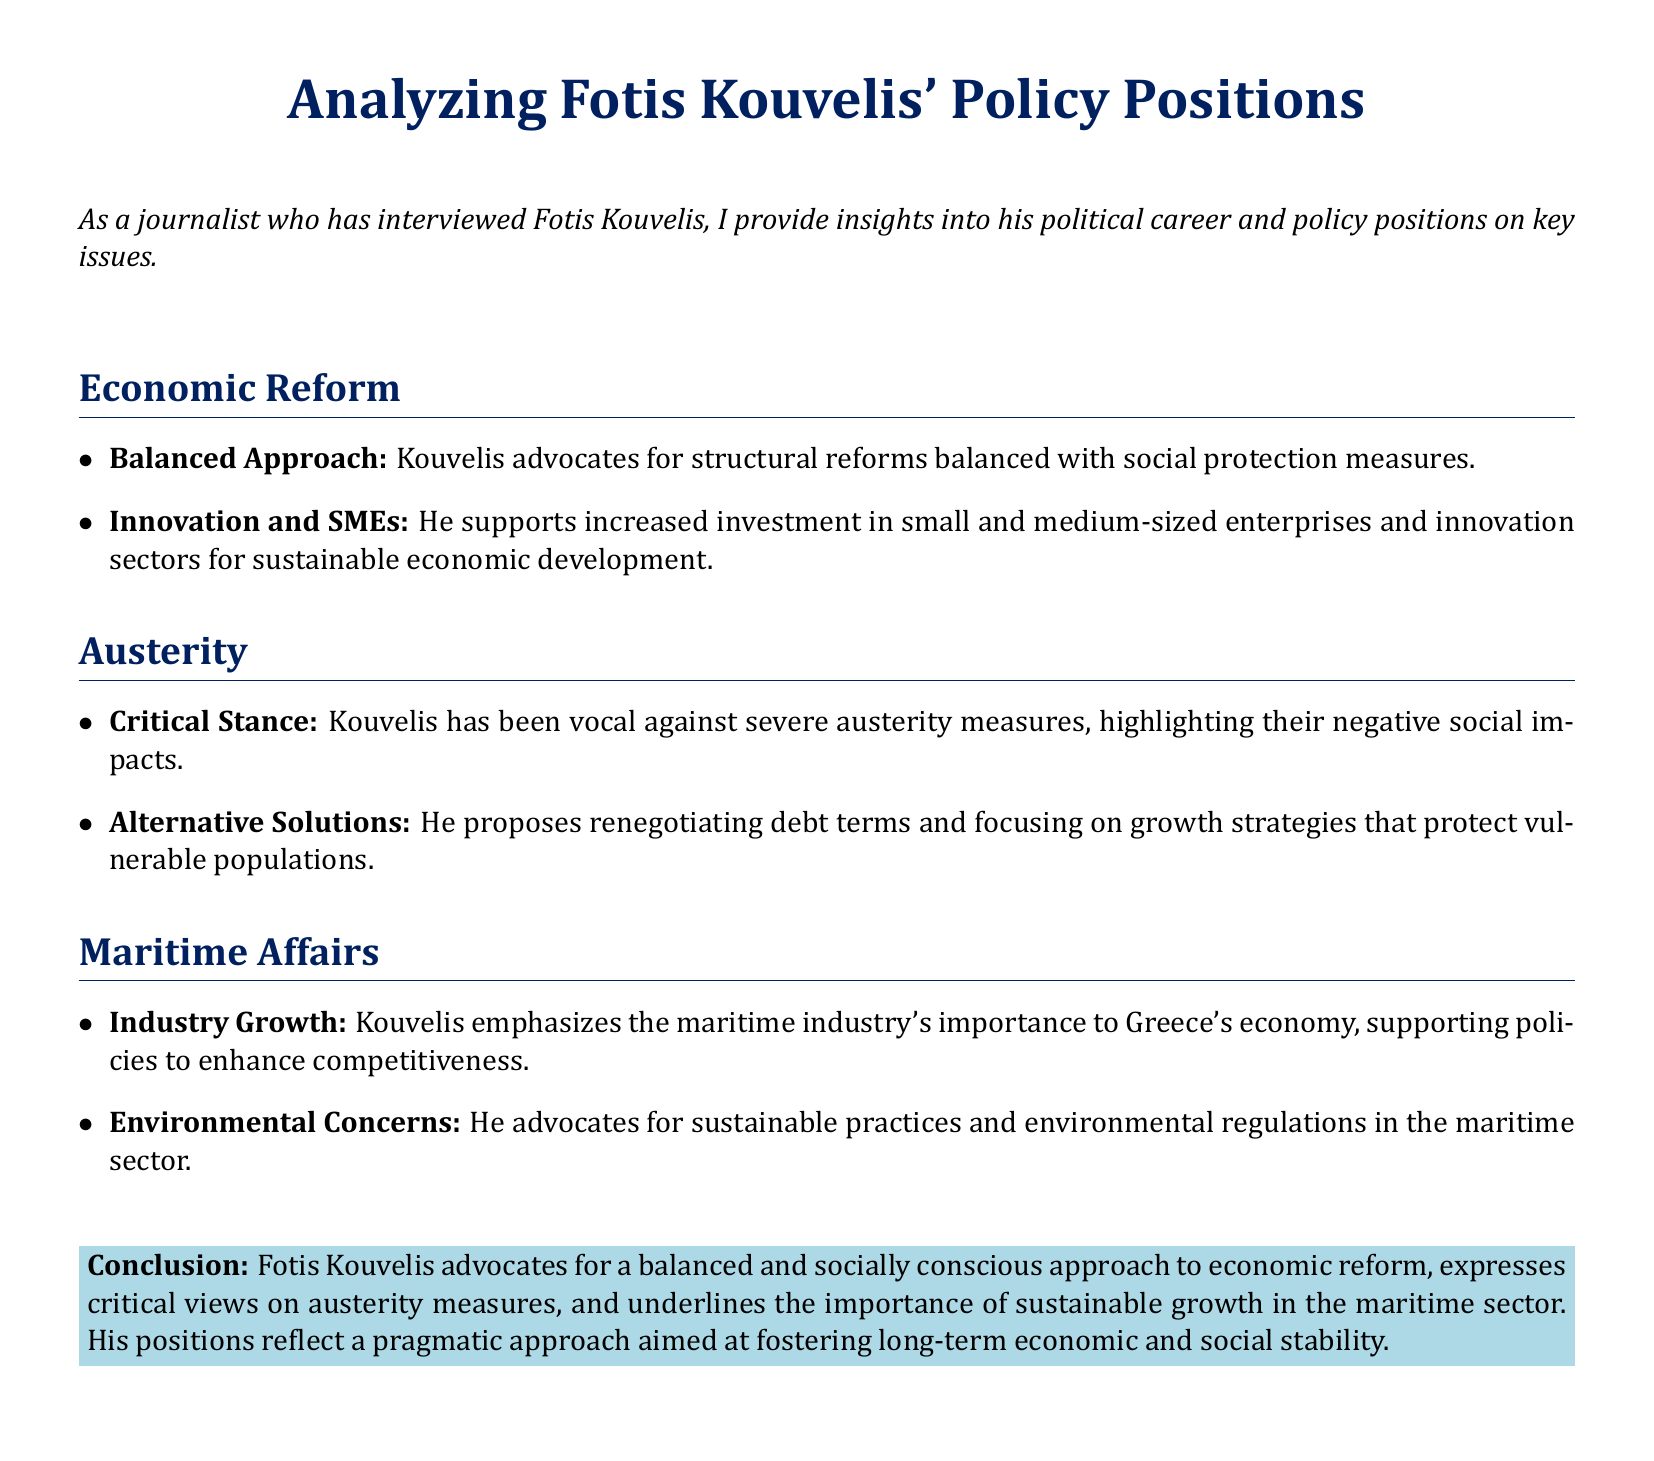What is Kouvelis' approach to economic reform? Kouvelis advocates for a balanced approach that includes structural reforms along with social protection measures.
Answer: Balanced Approach What sectors does Kouvelis support for investment? He supports increased investment in small and medium-sized enterprises and innovation sectors for sustainable economic development.
Answer: SMEs and Innovation What is Kouvelis' stance on austerity measures? Kouvelis has been vocal against severe austerity measures, citing their negative social impacts.
Answer: Critical Stance What alternative solutions does Kouvelis propose regarding austerity? He proposes renegotiating debt terms and focusing on growth strategies that protect vulnerable populations.
Answer: Renegotiating debt terms What does Kouvelis emphasize about the maritime industry? He emphasizes the importance of the maritime industry's role in Greece's economy and supports policies to enhance competitiveness.
Answer: Industry Growth What type of practices does Kouvelis advocate for in maritime affairs? He advocates for sustainable practices and environmental regulations in the maritime sector.
Answer: Sustainable practices What is the conclusion about Kouvelis' overall approach? His approach fosters long-term economic and social stability through a balanced and socially conscious method.
Answer: Socially conscious approach Which group does Kouvelis aim to protect through his proposed solutions? He focuses on protecting vulnerable populations through his proposed growth strategies.
Answer: Vulnerable populations 